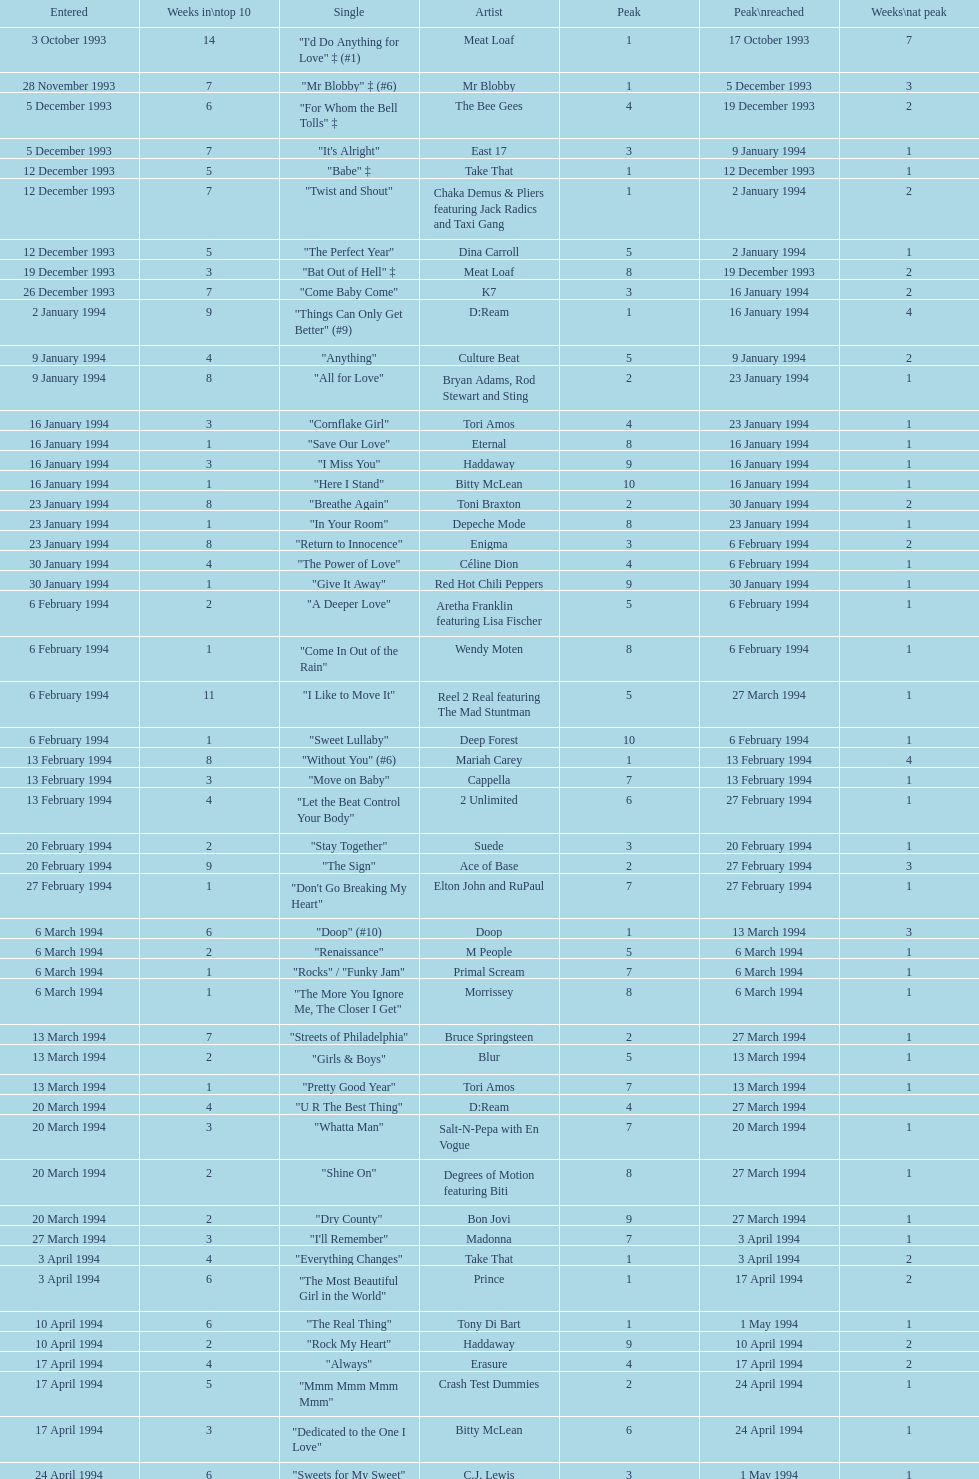Which artist came on the list after oasis? Tinman. 